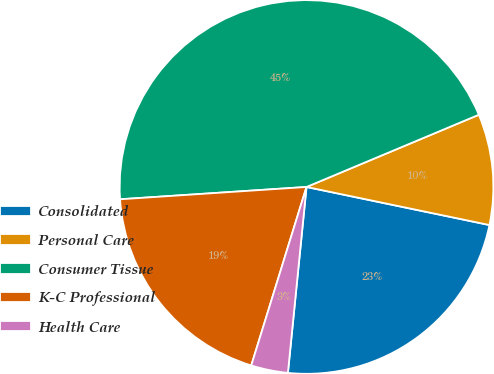Convert chart. <chart><loc_0><loc_0><loc_500><loc_500><pie_chart><fcel>Consolidated<fcel>Personal Care<fcel>Consumer Tissue<fcel>K-C Professional<fcel>Health Care<nl><fcel>23.32%<fcel>9.58%<fcel>44.73%<fcel>19.17%<fcel>3.19%<nl></chart> 